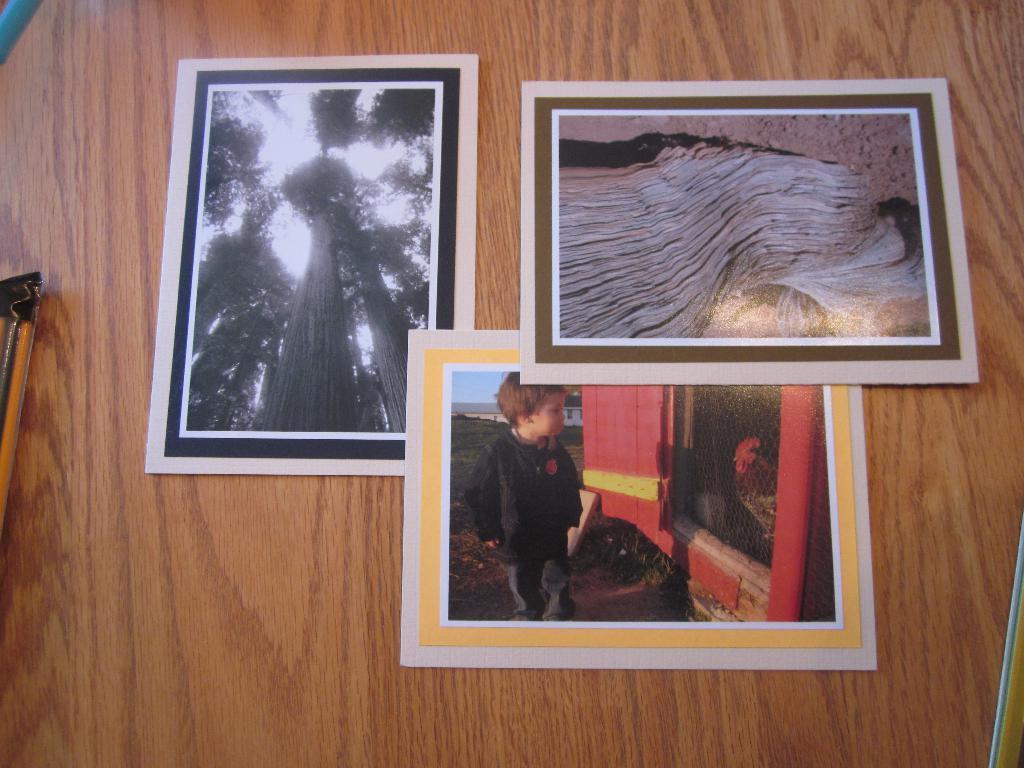In one or two sentences, can you explain what this image depicts? In this picture there are posters in the center of the image. 